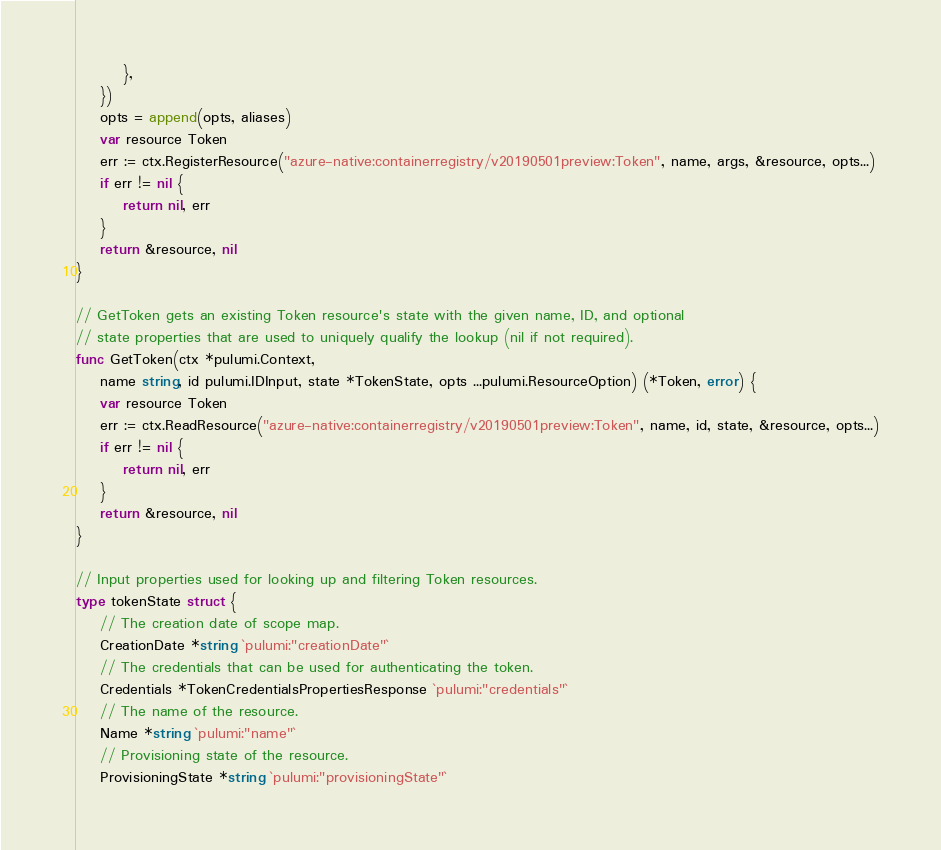<code> <loc_0><loc_0><loc_500><loc_500><_Go_>		},
	})
	opts = append(opts, aliases)
	var resource Token
	err := ctx.RegisterResource("azure-native:containerregistry/v20190501preview:Token", name, args, &resource, opts...)
	if err != nil {
		return nil, err
	}
	return &resource, nil
}

// GetToken gets an existing Token resource's state with the given name, ID, and optional
// state properties that are used to uniquely qualify the lookup (nil if not required).
func GetToken(ctx *pulumi.Context,
	name string, id pulumi.IDInput, state *TokenState, opts ...pulumi.ResourceOption) (*Token, error) {
	var resource Token
	err := ctx.ReadResource("azure-native:containerregistry/v20190501preview:Token", name, id, state, &resource, opts...)
	if err != nil {
		return nil, err
	}
	return &resource, nil
}

// Input properties used for looking up and filtering Token resources.
type tokenState struct {
	// The creation date of scope map.
	CreationDate *string `pulumi:"creationDate"`
	// The credentials that can be used for authenticating the token.
	Credentials *TokenCredentialsPropertiesResponse `pulumi:"credentials"`
	// The name of the resource.
	Name *string `pulumi:"name"`
	// Provisioning state of the resource.
	ProvisioningState *string `pulumi:"provisioningState"`</code> 